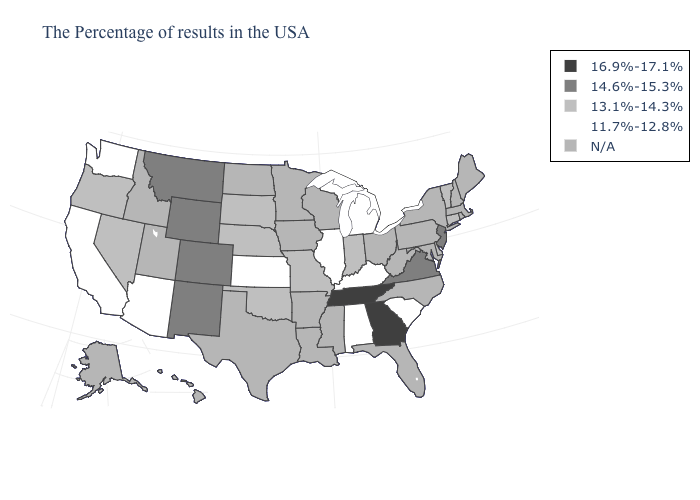What is the value of West Virginia?
Quick response, please. N/A. What is the value of Georgia?
Be succinct. 16.9%-17.1%. Does Kansas have the highest value in the MidWest?
Quick response, please. No. What is the value of New York?
Give a very brief answer. N/A. Name the states that have a value in the range N/A?
Write a very short answer. Maine, Massachusetts, Rhode Island, New Hampshire, New York, Maryland, Pennsylvania, North Carolina, West Virginia, Ohio, Florida, Wisconsin, Mississippi, Louisiana, Arkansas, Minnesota, Iowa, Texas, North Dakota, Utah, Idaho, Alaska, Hawaii. What is the highest value in the MidWest ?
Keep it brief. 13.1%-14.3%. Name the states that have a value in the range N/A?
Give a very brief answer. Maine, Massachusetts, Rhode Island, New Hampshire, New York, Maryland, Pennsylvania, North Carolina, West Virginia, Ohio, Florida, Wisconsin, Mississippi, Louisiana, Arkansas, Minnesota, Iowa, Texas, North Dakota, Utah, Idaho, Alaska, Hawaii. Does the map have missing data?
Short answer required. Yes. Is the legend a continuous bar?
Keep it brief. No. Name the states that have a value in the range 16.9%-17.1%?
Be succinct. Georgia, Tennessee. Which states have the highest value in the USA?
Be succinct. Georgia, Tennessee. Does California have the highest value in the USA?
Give a very brief answer. No. What is the lowest value in the South?
Write a very short answer. 11.7%-12.8%. What is the lowest value in states that border New Jersey?
Quick response, please. 13.1%-14.3%. 